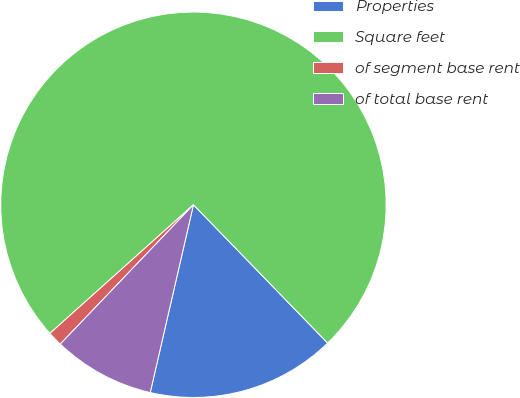<chart> <loc_0><loc_0><loc_500><loc_500><pie_chart><fcel>Properties<fcel>Square feet<fcel>of segment base rent<fcel>of total base rent<nl><fcel>15.86%<fcel>74.37%<fcel>1.23%<fcel>8.54%<nl></chart> 